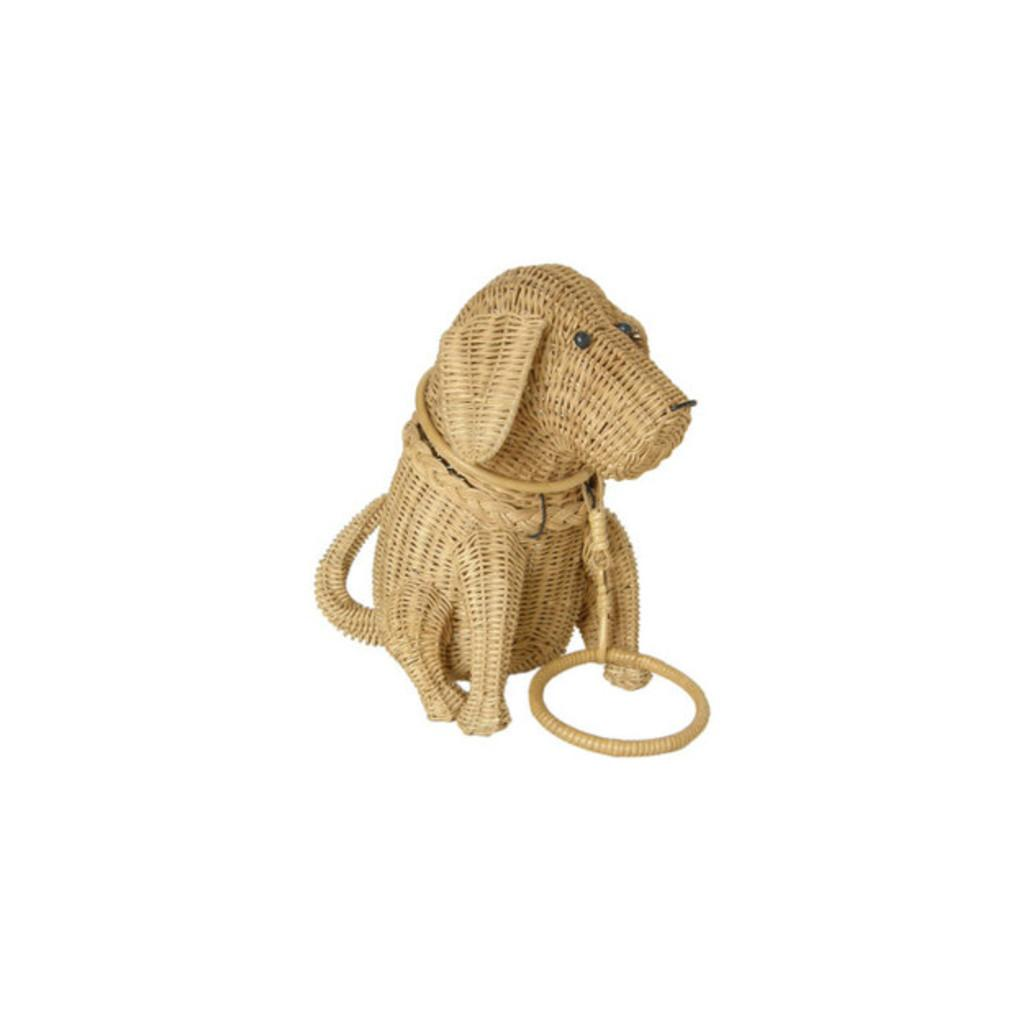What object can be seen in the picture? There is a toy in the picture. What color is the background of the picture? The background of the picture is white. How many ants are crawling on the toy in the picture? There are no ants present in the picture; it only features a toy and a white background. What type of apparel is the toy wearing in the picture? The toy is an inanimate object and does not wear apparel. 